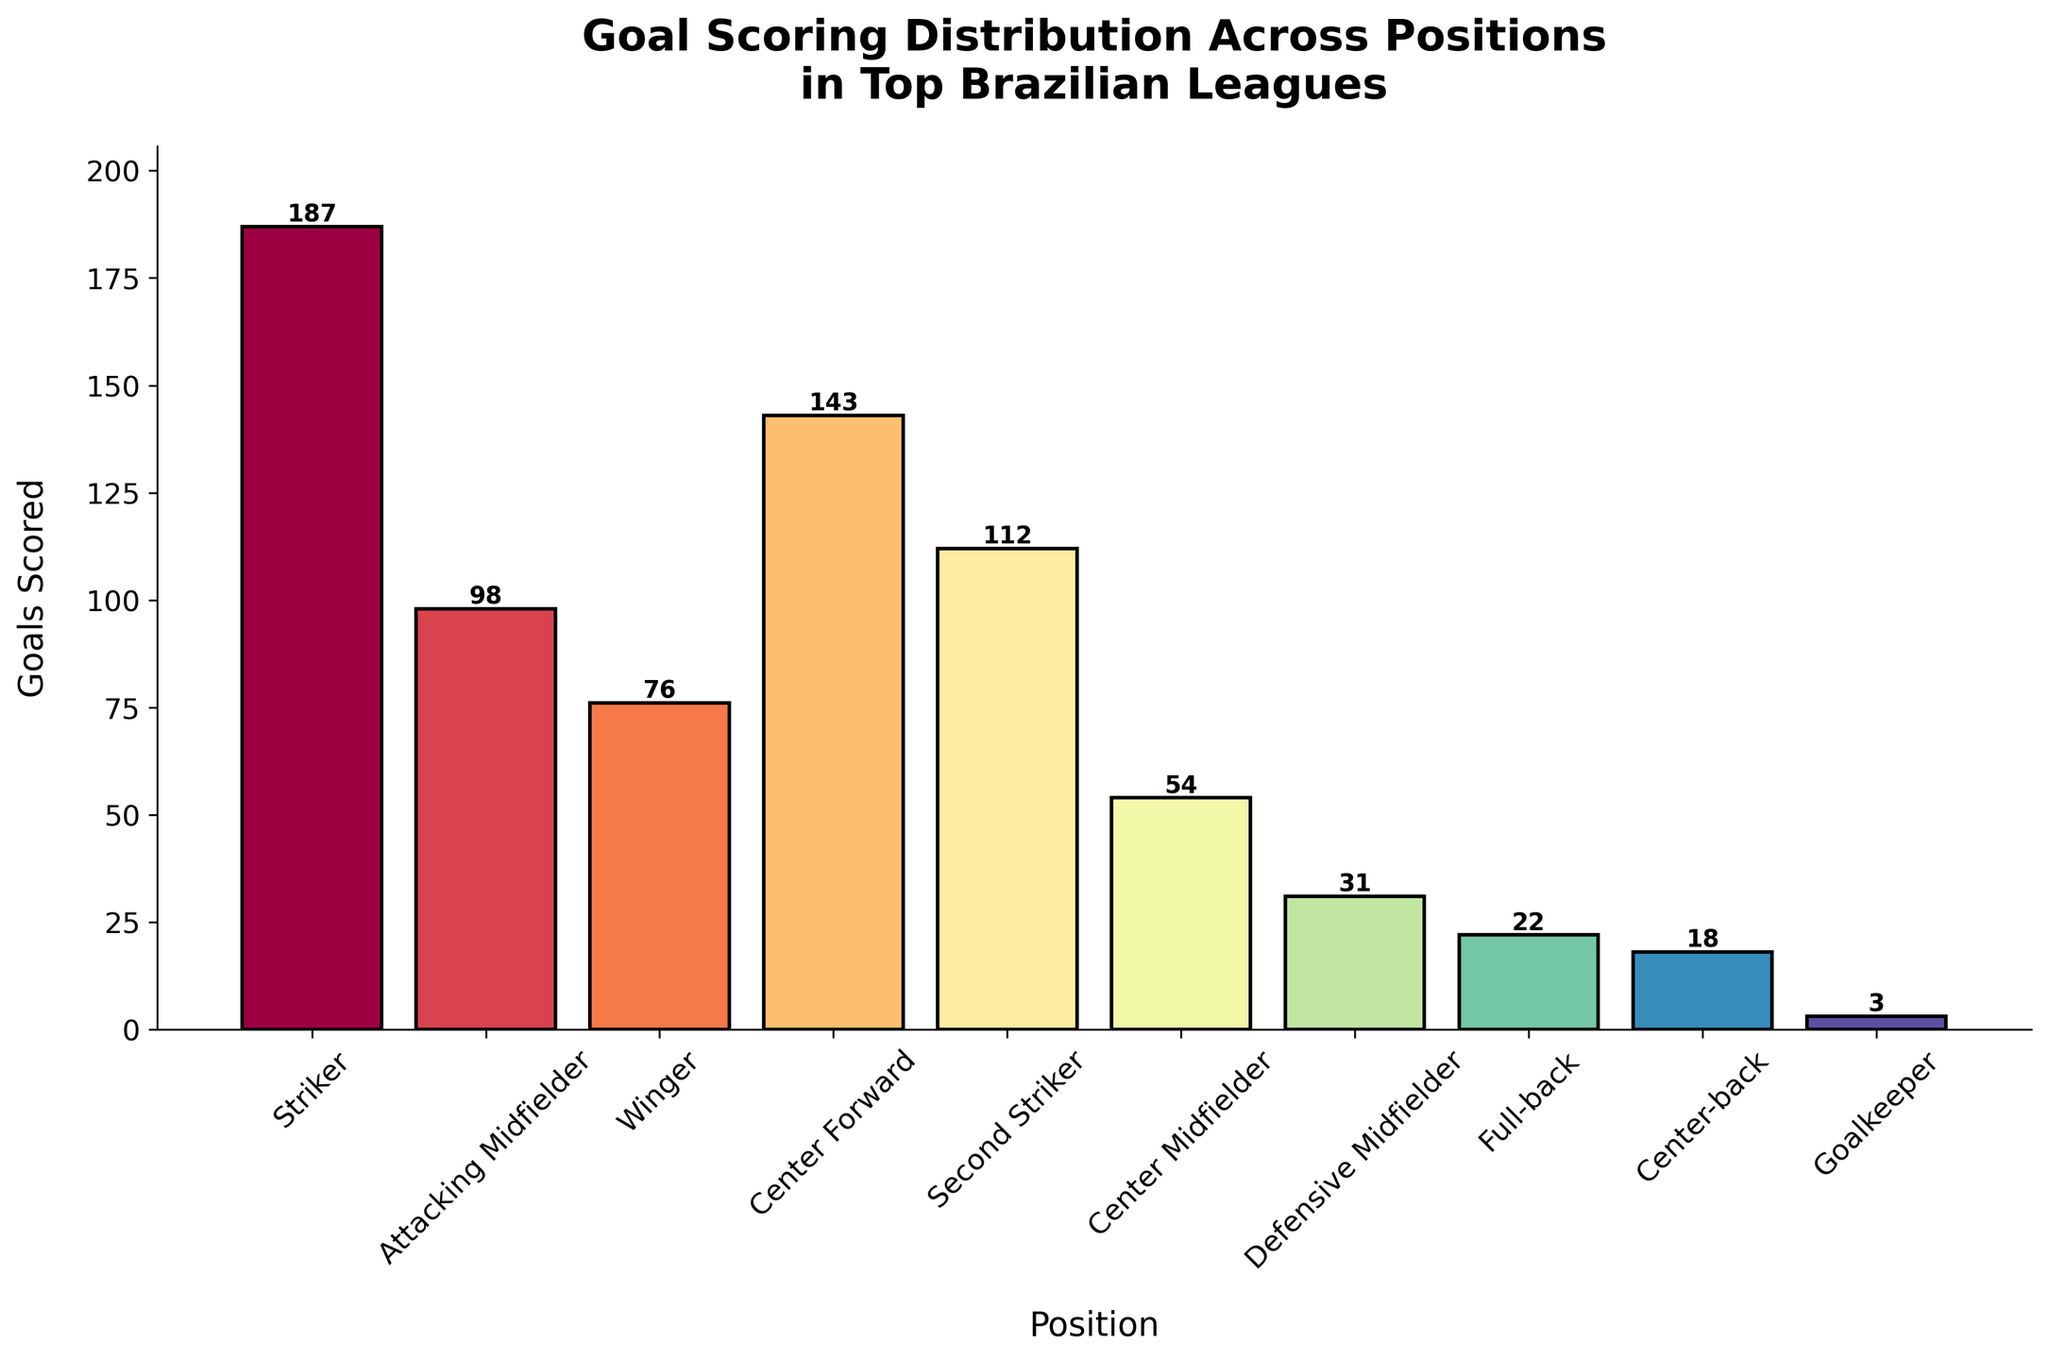What's the title of the histogram? The title is shown at the top of the histogram. It reads "Goal Scoring Distribution Across Positions\nin Top Brazilian Leagues".
Answer: Goal Scoring Distribution Across Positions in Top Brazilian Leagues What position has the highest number of goals scored? The position with the tallest bar in the histogram represents the highest number of goals. The tallest bar corresponds to the "Striker" position.
Answer: Striker Which position scored the fewest goals? The shortest bar in the histogram represents the fewest number of goals. The shortest bar corresponds to the "Goalkeeper" position.
Answer: Goalkeeper How many goals were scored by Center Forwards and Center Midfielders combined? Add the height values of the bars for Center Forward and Center Midfielder positions. The values are 143 and 54, respectively. 143 + 54 = 197
Answer: 197 What is the difference in goals scored between Strikers and Center Backs? Subtract the goals scored by Center Backs from those scored by Strikers. The values are 187 and 18, respectively. 187 - 18 = 169
Answer: 169 Which position scores more goals, Attacking Midfielders or Wingers? Compare the heights of the bars for Attacking Midfielders and Wingers positions. The bar for Attacking Midfielders is taller.
Answer: Attacking Midfielders What is the total number of goals scored by Defenders (Full-back and Center-back)? Add the goals scored by Full-backs and Center-backs. The values are 22 and 18, respectively. 22 + 18 = 40
Answer: 40 How many positions have scored over 100 goals? Count the bars that represent goal values over 100. There are three such bars for Striker, Center Forward, and Second Striker positions.
Answer: 3 By how much do the goals scored by Wingers exceed those scored by Defensive Midfielders? Subtract the goals scored by Defensive Midfielders from those scored by Wingers. The values are 76 and 31, respectively. 76 - 31 = 45
Answer: 45 What is the average number of goals scored by the top 4 goal-scoring positions? Identify the top 4 positions by goal counts: Striker (187), Center Forward (143), Second Striker (112), and Attacking Midfielder (98). Sum these values and divide by 4. (187 + 143 + 112 + 98) / 4 = 540 / 4 = 135
Answer: 135 